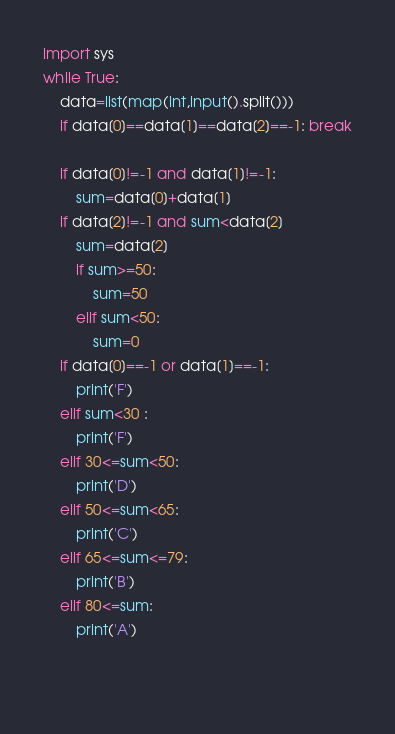<code> <loc_0><loc_0><loc_500><loc_500><_Python_>import sys
while True:
	data=list(map(int,input().split()))
	if data[0]==data[1]==data[2]==-1: break
	
	if data[0]!=-1 and data[1]!=-1:
		sum=data[0]+data[1]
	if data[2]!=-1 and sum<data[2]
		sum=data[2]
		if sum>=50:
			sum=50
		elif sum<50:
			sum=0
	if data[0]==-1 or data[1]==-1:
		print('F')
	elif sum<30 :
		print('F')
	elif 30<=sum<50:
		print('D')
	elif 50<=sum<65:
		print('C')
	elif 65<=sum<=79:
		print('B')
	elif 80<=sum:
		print('A')
		
	</code> 